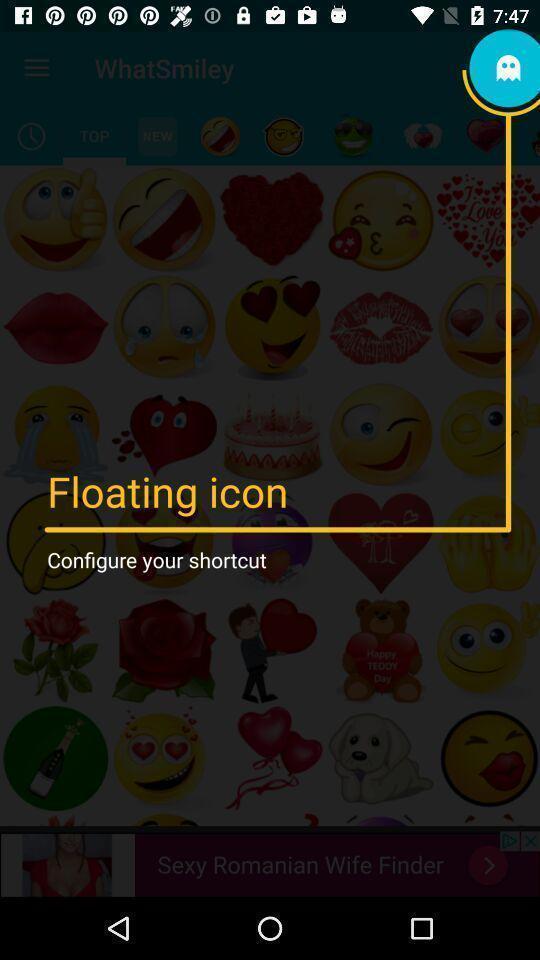Provide a detailed account of this screenshot. Screen showing floating icon. 